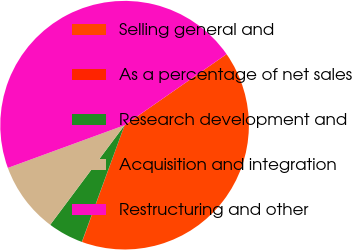Convert chart to OTSL. <chart><loc_0><loc_0><loc_500><loc_500><pie_chart><fcel>Selling general and<fcel>As a percentage of net sales<fcel>Research development and<fcel>Acquisition and integration<fcel>Restructuring and other<nl><fcel>40.24%<fcel>0.03%<fcel>4.62%<fcel>9.21%<fcel>45.9%<nl></chart> 